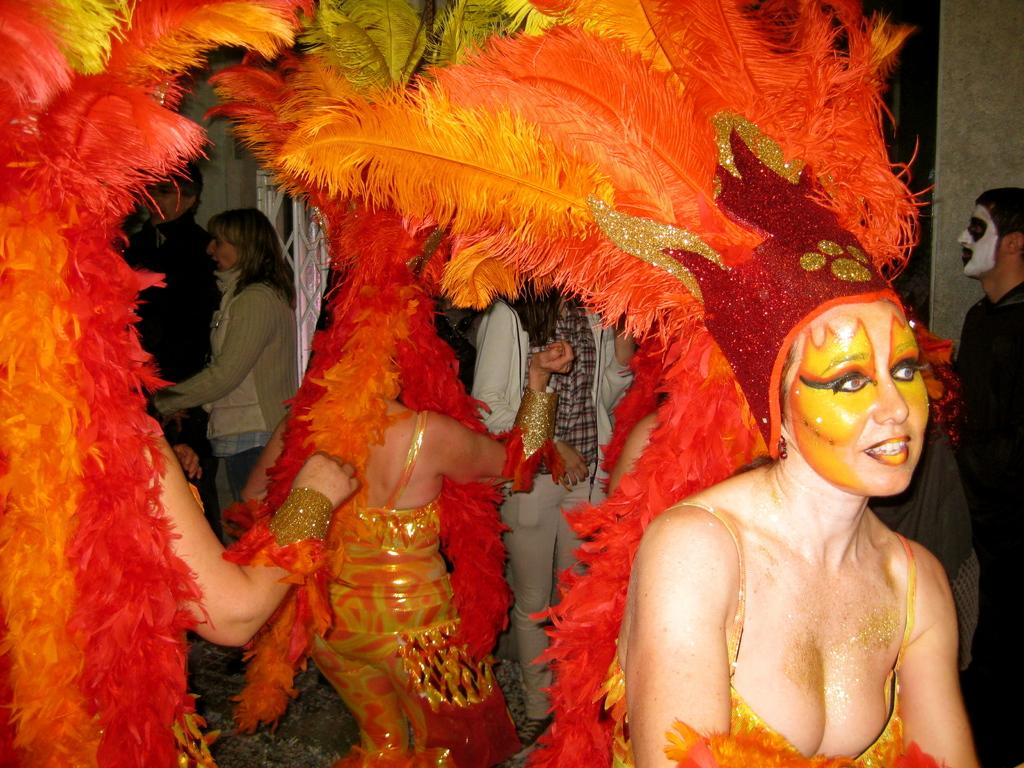What can be observed about the people in the image? There are groups of people standing in the image. What are some of the people wearing? Some people are wearing fancy dresses. What type of structure can be seen in the image? There appears to be a wall in the image. Is there any specific object mentioned that might be present in the image? There might be an iron pillar in the image, but this is less certain based on the transcript. What is the reason behind the lizards gathering around the people in the image? There are no lizards present in the image, so there is no reason for them to gather around the people. 